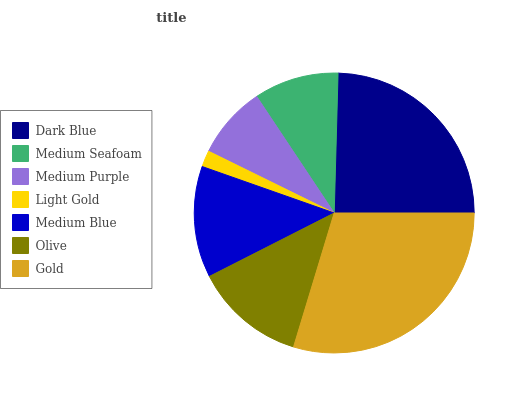Is Light Gold the minimum?
Answer yes or no. Yes. Is Gold the maximum?
Answer yes or no. Yes. Is Medium Seafoam the minimum?
Answer yes or no. No. Is Medium Seafoam the maximum?
Answer yes or no. No. Is Dark Blue greater than Medium Seafoam?
Answer yes or no. Yes. Is Medium Seafoam less than Dark Blue?
Answer yes or no. Yes. Is Medium Seafoam greater than Dark Blue?
Answer yes or no. No. Is Dark Blue less than Medium Seafoam?
Answer yes or no. No. Is Olive the high median?
Answer yes or no. Yes. Is Olive the low median?
Answer yes or no. Yes. Is Medium Seafoam the high median?
Answer yes or no. No. Is Gold the low median?
Answer yes or no. No. 